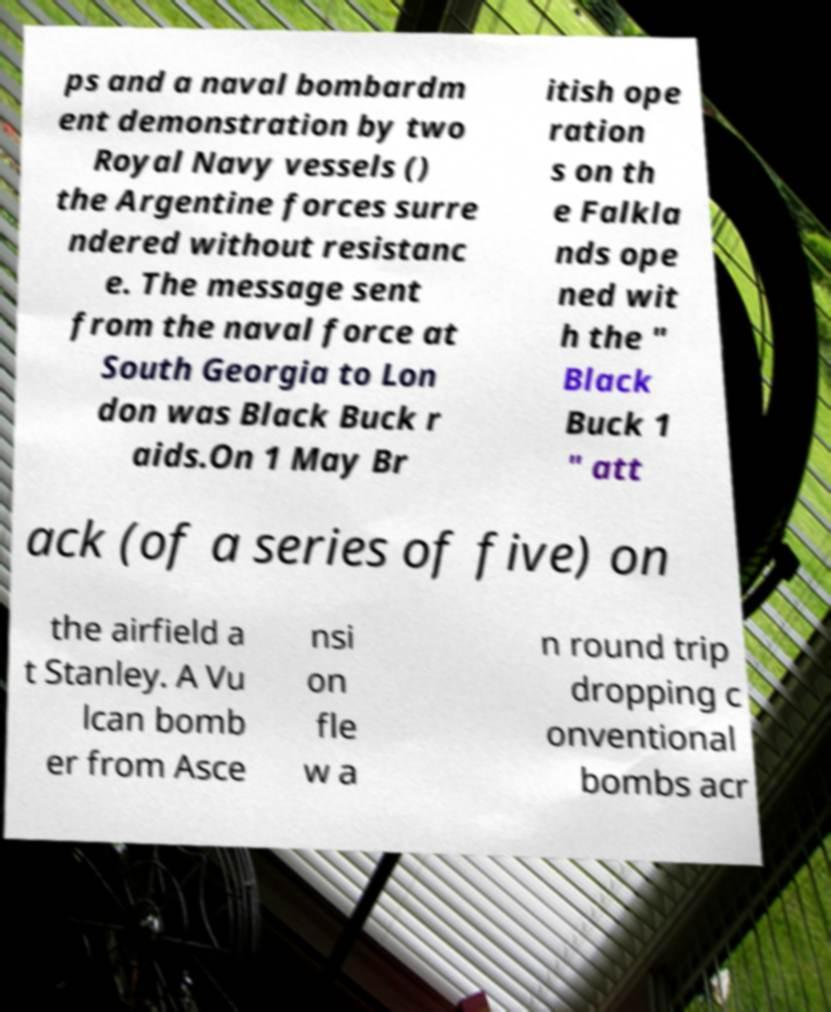Could you extract and type out the text from this image? ps and a naval bombardm ent demonstration by two Royal Navy vessels () the Argentine forces surre ndered without resistanc e. The message sent from the naval force at South Georgia to Lon don was Black Buck r aids.On 1 May Br itish ope ration s on th e Falkla nds ope ned wit h the " Black Buck 1 " att ack (of a series of five) on the airfield a t Stanley. A Vu lcan bomb er from Asce nsi on fle w a n round trip dropping c onventional bombs acr 